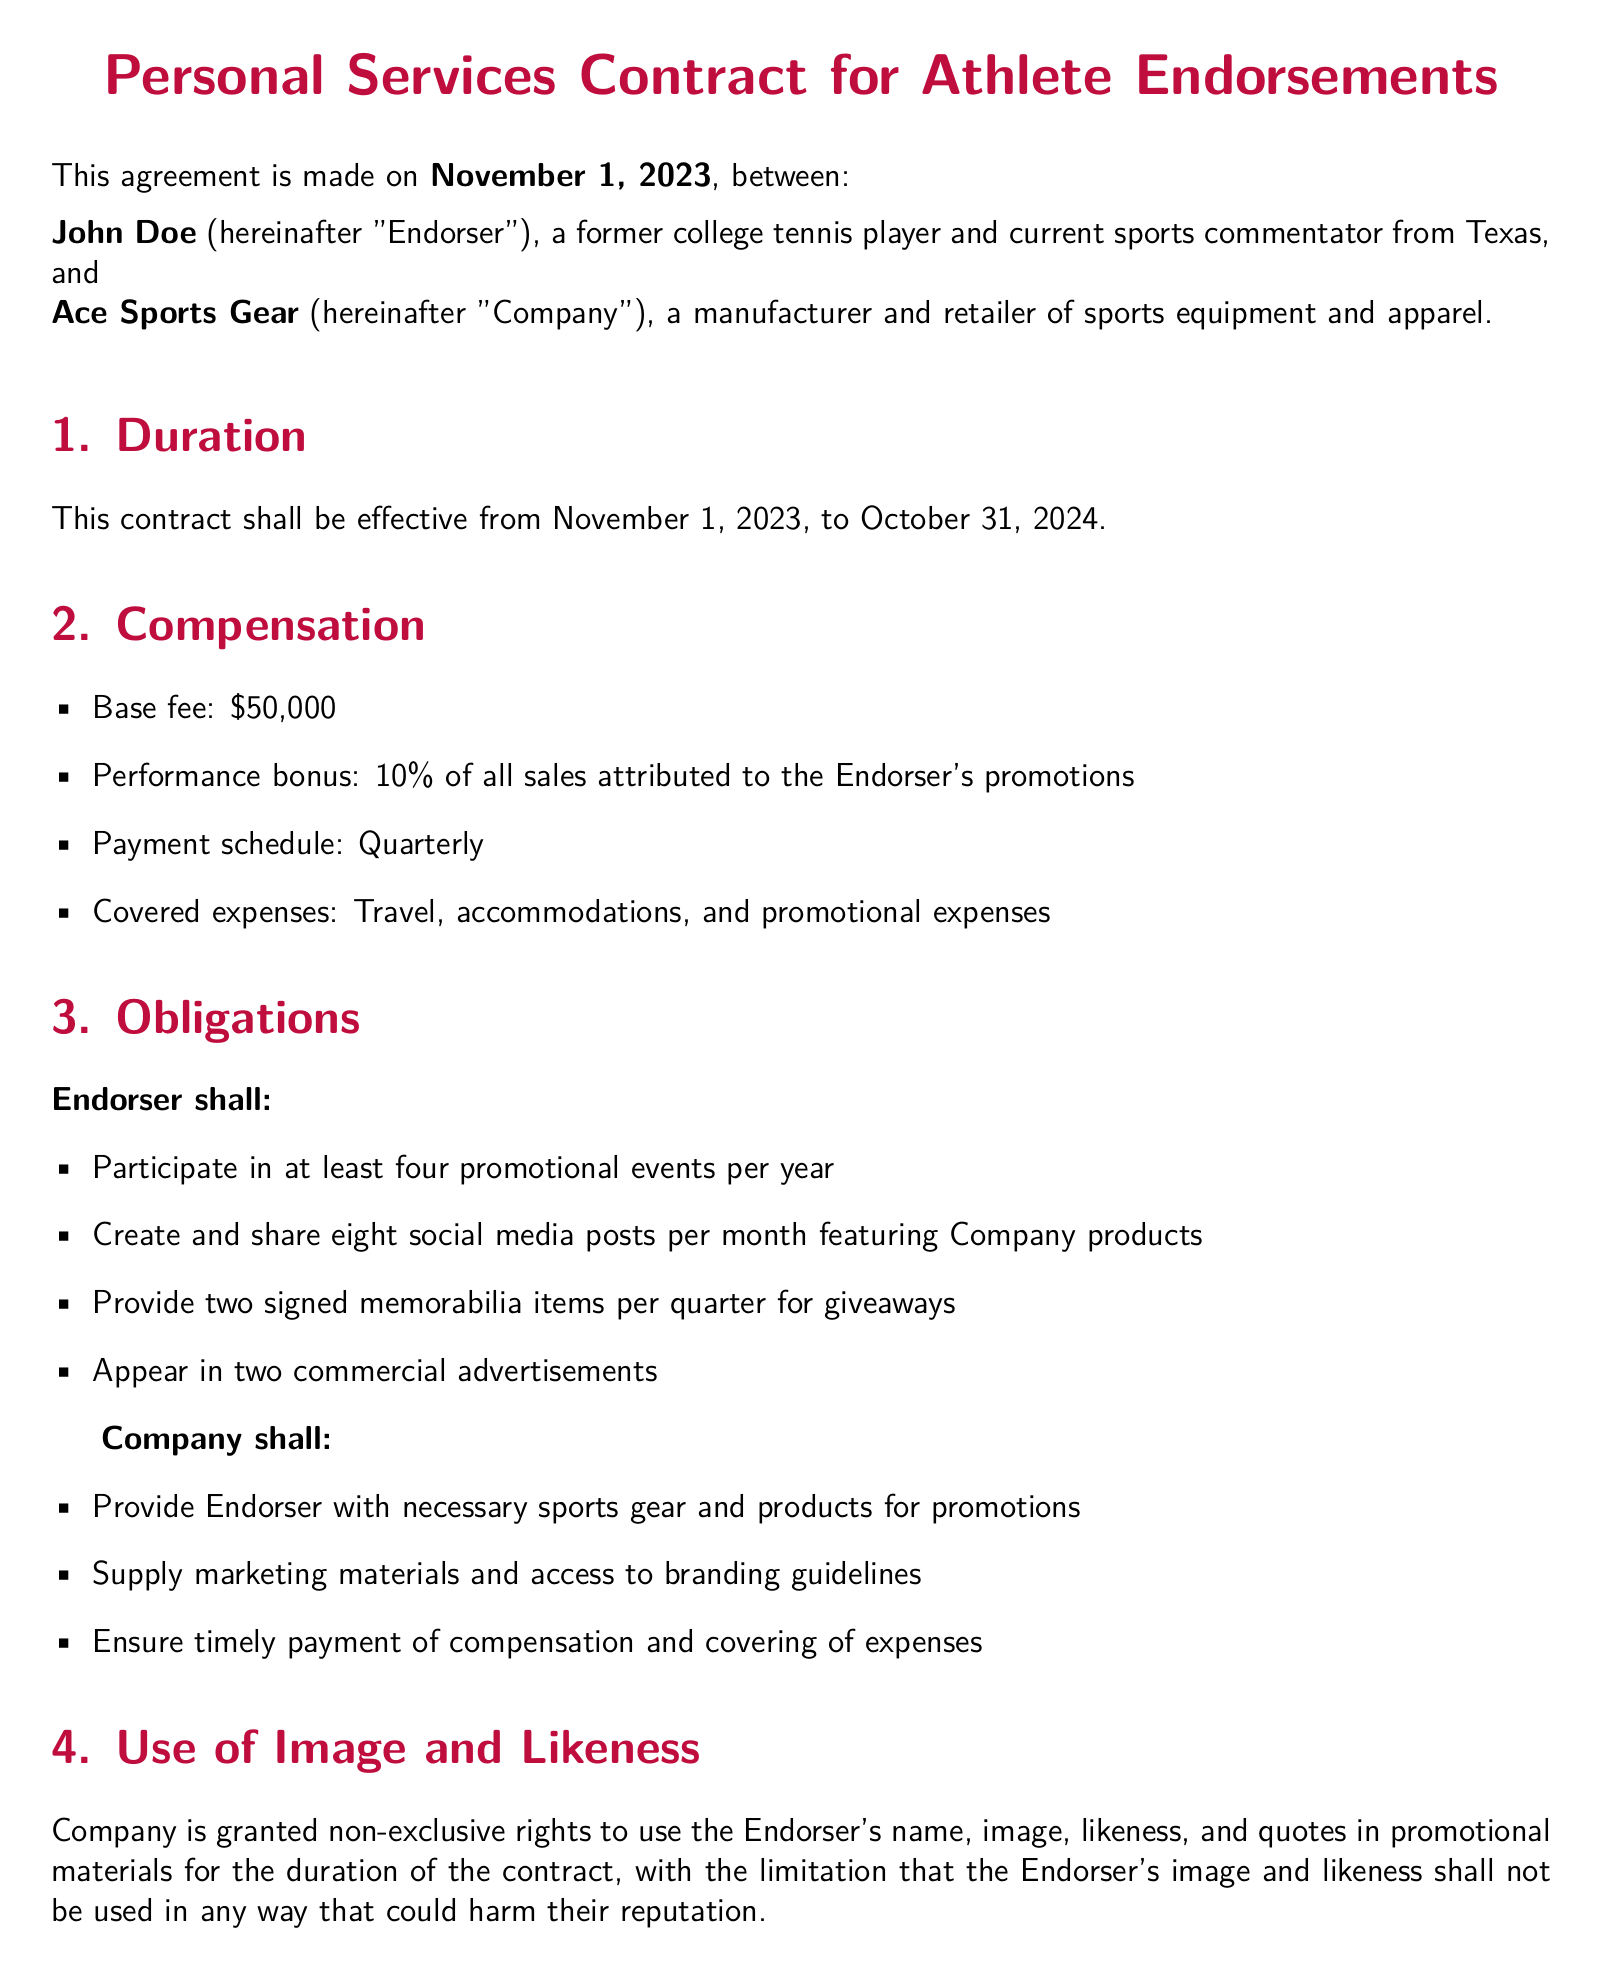What is the effective date of the contract? The effective date is mentioned in the first section of the contract.
Answer: November 1, 2023 What is the base fee for the Endorser? The base fee is located under the Compensation section.
Answer: $50,000 How many promotional events must the Endorser participate in per year? This information is specified under the Obligations of the Endorser.
Answer: Four What percentage is the performance bonus based on sales? The performance bonus percentage is detailed in the Compensation section.
Answer: 10% What are the grounds for termination of the contract? The conditions for termination are listed in the Termination section.
Answer: Moral turpitude, material breach, promotional failure How long after the contract ends must confidentiality be maintained? The confidentiality section specifies this timeframe.
Answer: Two years Who will supply marketing materials to the Endorser? This responsibility is outlined in the Company's obligations.
Answer: Company In which state is this contract governed? The governing law is mentioned in the last section of the document.
Answer: Texas 